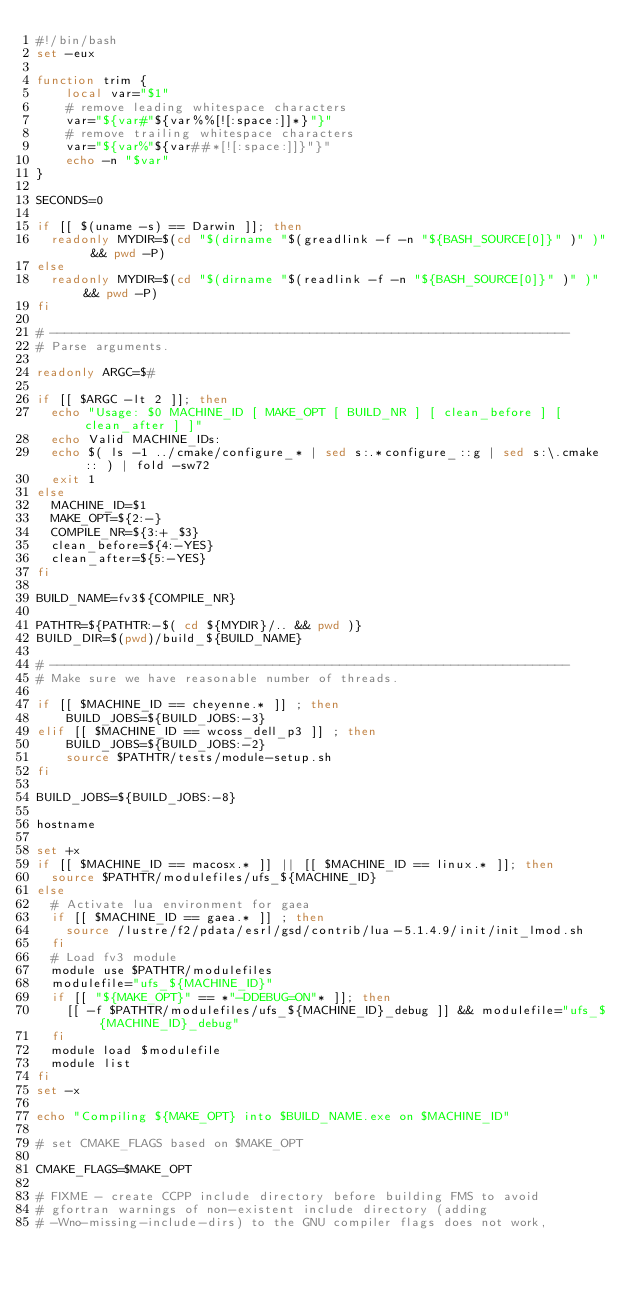<code> <loc_0><loc_0><loc_500><loc_500><_Bash_>#!/bin/bash
set -eux

function trim {
    local var="$1"
    # remove leading whitespace characters
    var="${var#"${var%%[![:space:]]*}"}"
    # remove trailing whitespace characters
    var="${var%"${var##*[![:space:]]}"}"
    echo -n "$var"
}

SECONDS=0

if [[ $(uname -s) == Darwin ]]; then
  readonly MYDIR=$(cd "$(dirname "$(greadlink -f -n "${BASH_SOURCE[0]}" )" )" && pwd -P)
else
  readonly MYDIR=$(cd "$(dirname "$(readlink -f -n "${BASH_SOURCE[0]}" )" )" && pwd -P)
fi

# ----------------------------------------------------------------------
# Parse arguments.

readonly ARGC=$#

if [[ $ARGC -lt 2 ]]; then
  echo "Usage: $0 MACHINE_ID [ MAKE_OPT [ BUILD_NR ] [ clean_before ] [ clean_after ] ]"
  echo Valid MACHINE_IDs:
  echo $( ls -1 ../cmake/configure_* | sed s:.*configure_::g | sed s:\.cmake:: ) | fold -sw72
  exit 1
else
  MACHINE_ID=$1
  MAKE_OPT=${2:-}
  COMPILE_NR=${3:+_$3}
  clean_before=${4:-YES}
  clean_after=${5:-YES}
fi

BUILD_NAME=fv3${COMPILE_NR}

PATHTR=${PATHTR:-$( cd ${MYDIR}/.. && pwd )}
BUILD_DIR=$(pwd)/build_${BUILD_NAME}

# ----------------------------------------------------------------------
# Make sure we have reasonable number of threads.

if [[ $MACHINE_ID == cheyenne.* ]] ; then
    BUILD_JOBS=${BUILD_JOBS:-3}
elif [[ $MACHINE_ID == wcoss_dell_p3 ]] ; then
    BUILD_JOBS=${BUILD_JOBS:-2}
    source $PATHTR/tests/module-setup.sh
fi

BUILD_JOBS=${BUILD_JOBS:-8}

hostname

set +x
if [[ $MACHINE_ID == macosx.* ]] || [[ $MACHINE_ID == linux.* ]]; then
  source $PATHTR/modulefiles/ufs_${MACHINE_ID}
else
  # Activate lua environment for gaea
  if [[ $MACHINE_ID == gaea.* ]] ; then
    source /lustre/f2/pdata/esrl/gsd/contrib/lua-5.1.4.9/init/init_lmod.sh
  fi
  # Load fv3 module
  module use $PATHTR/modulefiles
  modulefile="ufs_${MACHINE_ID}"
  if [[ "${MAKE_OPT}" == *"-DDEBUG=ON"* ]]; then
    [[ -f $PATHTR/modulefiles/ufs_${MACHINE_ID}_debug ]] && modulefile="ufs_${MACHINE_ID}_debug"
  fi
  module load $modulefile
  module list
fi
set -x

echo "Compiling ${MAKE_OPT} into $BUILD_NAME.exe on $MACHINE_ID"

# set CMAKE_FLAGS based on $MAKE_OPT

CMAKE_FLAGS=$MAKE_OPT

# FIXME - create CCPP include directory before building FMS to avoid
# gfortran warnings of non-existent include directory (adding
# -Wno-missing-include-dirs) to the GNU compiler flags does not work,</code> 